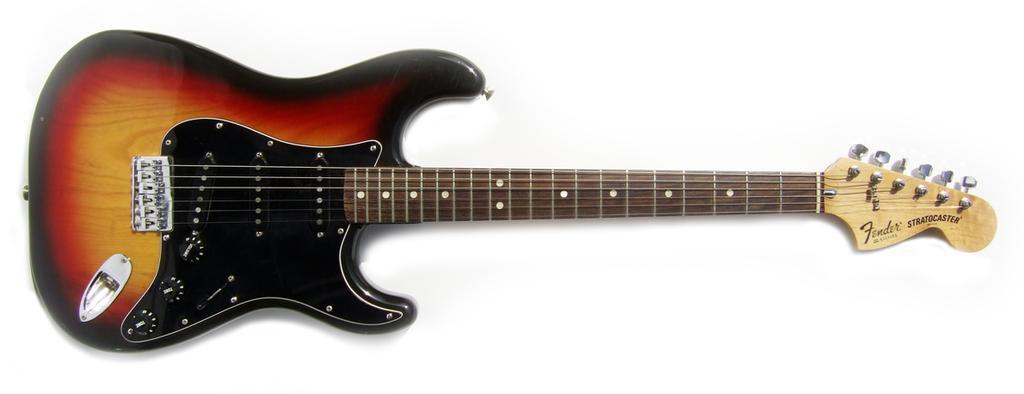Please provide a concise description of this image. In this picture we can see a guitar with red and black combination and it is beautifully placed. 